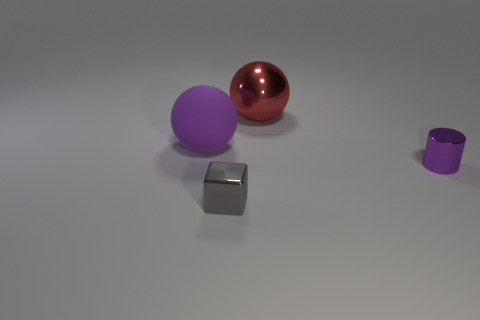Subtract all cyan balls. Subtract all yellow cubes. How many balls are left? 2 Add 2 large gray metallic cylinders. How many objects exist? 6 Subtract all cylinders. How many objects are left? 3 Subtract 1 purple balls. How many objects are left? 3 Subtract all tiny purple metallic cylinders. Subtract all gray shiny blocks. How many objects are left? 2 Add 2 gray metal things. How many gray metal things are left? 3 Add 2 red metallic objects. How many red metallic objects exist? 3 